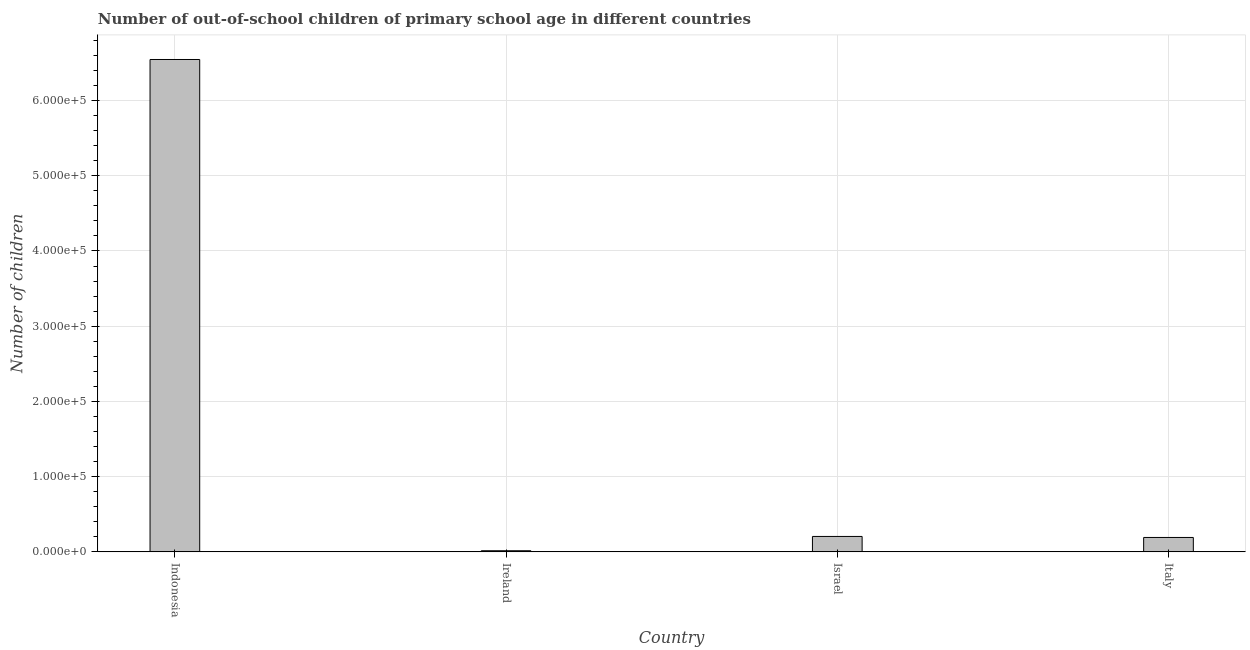Does the graph contain any zero values?
Your response must be concise. No. What is the title of the graph?
Provide a succinct answer. Number of out-of-school children of primary school age in different countries. What is the label or title of the Y-axis?
Ensure brevity in your answer.  Number of children. What is the number of out-of-school children in Indonesia?
Make the answer very short. 6.55e+05. Across all countries, what is the maximum number of out-of-school children?
Provide a succinct answer. 6.55e+05. Across all countries, what is the minimum number of out-of-school children?
Provide a short and direct response. 1498. In which country was the number of out-of-school children minimum?
Give a very brief answer. Ireland. What is the sum of the number of out-of-school children?
Give a very brief answer. 6.96e+05. What is the difference between the number of out-of-school children in Indonesia and Israel?
Your answer should be compact. 6.34e+05. What is the average number of out-of-school children per country?
Give a very brief answer. 1.74e+05. What is the median number of out-of-school children?
Ensure brevity in your answer.  1.98e+04. In how many countries, is the number of out-of-school children greater than 500000 ?
Your answer should be compact. 1. What is the ratio of the number of out-of-school children in Indonesia to that in Ireland?
Make the answer very short. 436.93. What is the difference between the highest and the second highest number of out-of-school children?
Keep it short and to the point. 6.34e+05. Is the sum of the number of out-of-school children in Indonesia and Israel greater than the maximum number of out-of-school children across all countries?
Keep it short and to the point. Yes. What is the difference between the highest and the lowest number of out-of-school children?
Your answer should be very brief. 6.53e+05. In how many countries, is the number of out-of-school children greater than the average number of out-of-school children taken over all countries?
Provide a short and direct response. 1. How many bars are there?
Keep it short and to the point. 4. What is the difference between two consecutive major ticks on the Y-axis?
Provide a short and direct response. 1.00e+05. Are the values on the major ticks of Y-axis written in scientific E-notation?
Your answer should be compact. Yes. What is the Number of children of Indonesia?
Provide a short and direct response. 6.55e+05. What is the Number of children in Ireland?
Provide a succinct answer. 1498. What is the Number of children in Israel?
Offer a terse response. 2.05e+04. What is the Number of children of Italy?
Ensure brevity in your answer.  1.92e+04. What is the difference between the Number of children in Indonesia and Ireland?
Provide a succinct answer. 6.53e+05. What is the difference between the Number of children in Indonesia and Israel?
Offer a very short reply. 6.34e+05. What is the difference between the Number of children in Indonesia and Italy?
Keep it short and to the point. 6.35e+05. What is the difference between the Number of children in Ireland and Israel?
Your answer should be very brief. -1.90e+04. What is the difference between the Number of children in Ireland and Italy?
Your answer should be compact. -1.77e+04. What is the difference between the Number of children in Israel and Italy?
Make the answer very short. 1362. What is the ratio of the Number of children in Indonesia to that in Ireland?
Make the answer very short. 436.93. What is the ratio of the Number of children in Indonesia to that in Israel?
Your answer should be very brief. 31.9. What is the ratio of the Number of children in Indonesia to that in Italy?
Your response must be concise. 34.17. What is the ratio of the Number of children in Ireland to that in Israel?
Offer a terse response. 0.07. What is the ratio of the Number of children in Ireland to that in Italy?
Your answer should be compact. 0.08. What is the ratio of the Number of children in Israel to that in Italy?
Provide a short and direct response. 1.07. 